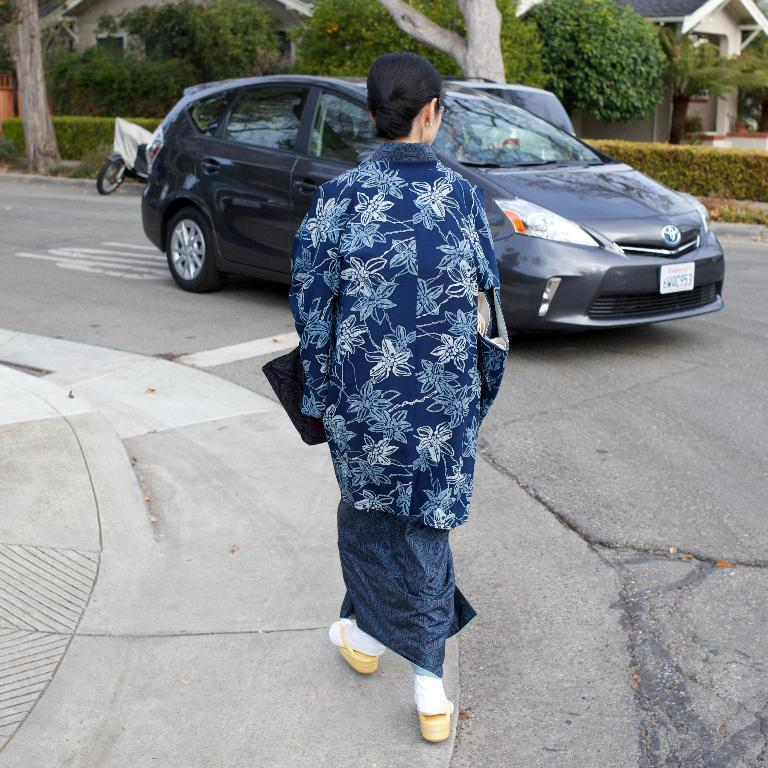What is the woman in the image doing? The woman is walking in the image. What can be seen on the road in the image? A vehicle is present on the road. What is visible in the background of the image? Trees, plants, a motorbike, and houses are visible in the background of the image. How does the woman compare her loss to the lumber in the image? There is no mention of loss or lumber in the image, so it is not possible to answer this question. 